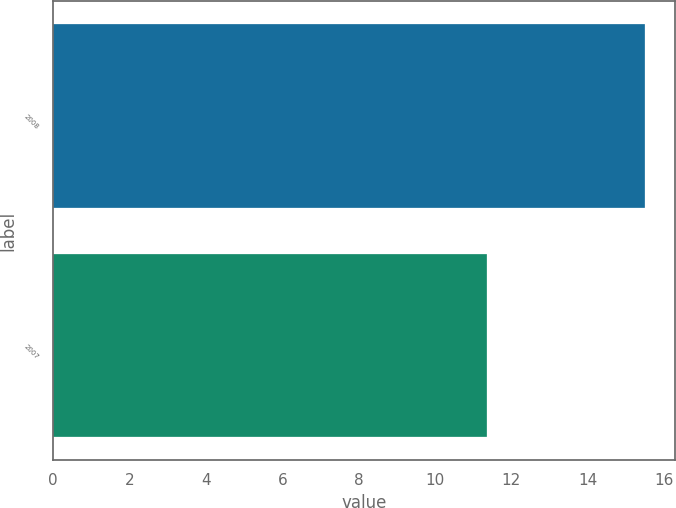Convert chart to OTSL. <chart><loc_0><loc_0><loc_500><loc_500><bar_chart><fcel>2008<fcel>2007<nl><fcel>15.5<fcel>11.36<nl></chart> 